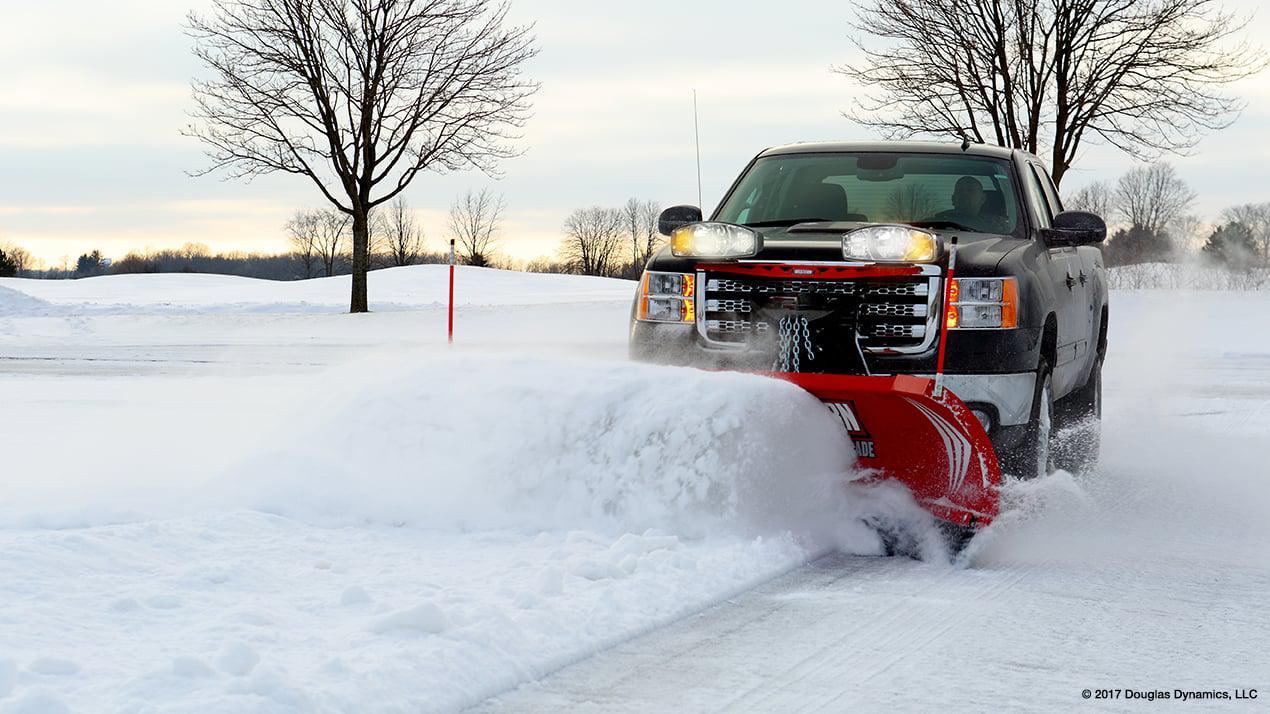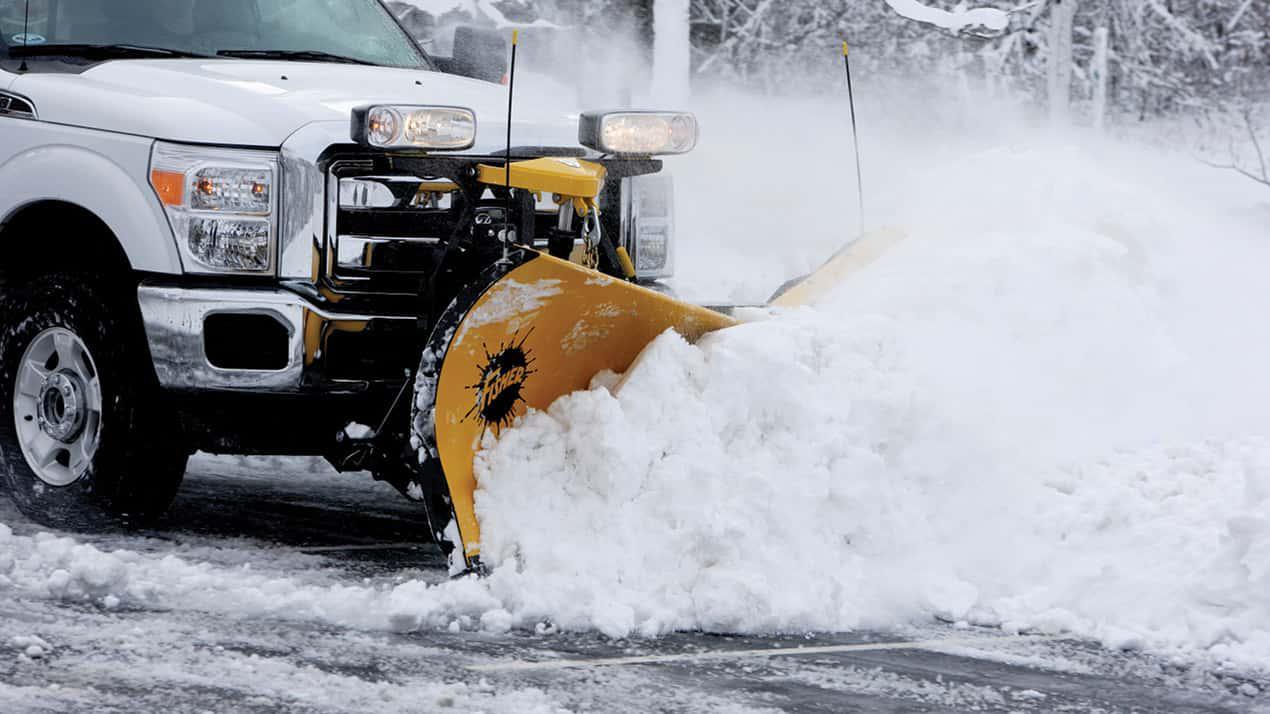The first image is the image on the left, the second image is the image on the right. Assess this claim about the two images: "An image shows at least one yellow truck clearing snow with a plow.". Correct or not? Answer yes or no. No. The first image is the image on the left, the second image is the image on the right. Given the left and right images, does the statement "The left image contains at least two snow plows." hold true? Answer yes or no. No. 